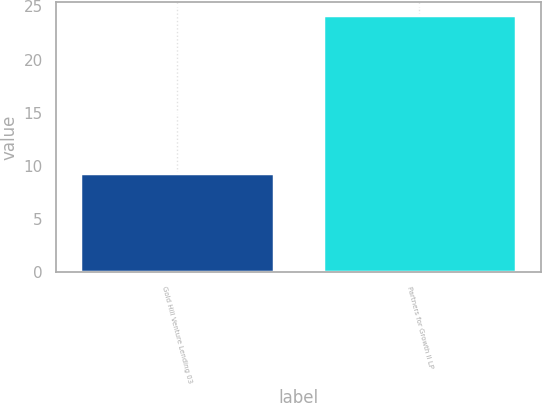Convert chart. <chart><loc_0><loc_0><loc_500><loc_500><bar_chart><fcel>Gold Hill Venture Lending 03<fcel>Partners for Growth II LP<nl><fcel>9.3<fcel>24.2<nl></chart> 